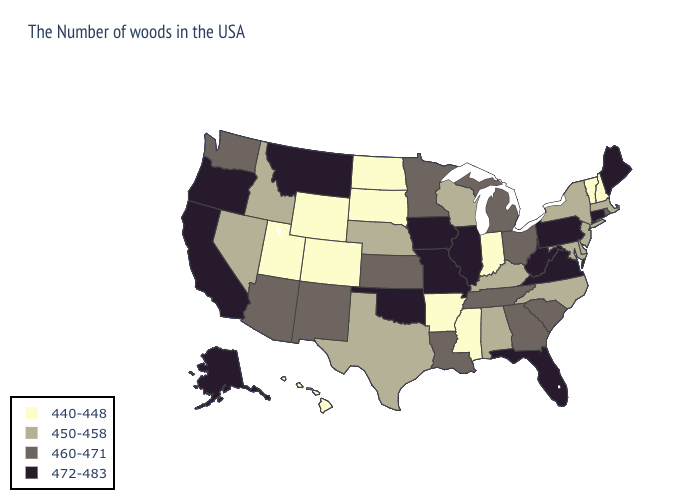Does Louisiana have the lowest value in the South?
Short answer required. No. Does Montana have the highest value in the USA?
Short answer required. Yes. Does Vermont have a lower value than Wyoming?
Keep it brief. No. Does Montana have the highest value in the West?
Keep it brief. Yes. Which states hav the highest value in the Northeast?
Give a very brief answer. Maine, Connecticut, Pennsylvania. Name the states that have a value in the range 472-483?
Write a very short answer. Maine, Connecticut, Pennsylvania, Virginia, West Virginia, Florida, Illinois, Missouri, Iowa, Oklahoma, Montana, California, Oregon, Alaska. What is the highest value in the USA?
Concise answer only. 472-483. What is the lowest value in the USA?
Keep it brief. 440-448. Which states have the lowest value in the USA?
Give a very brief answer. New Hampshire, Vermont, Indiana, Mississippi, Arkansas, South Dakota, North Dakota, Wyoming, Colorado, Utah, Hawaii. Which states hav the highest value in the MidWest?
Quick response, please. Illinois, Missouri, Iowa. What is the lowest value in the MidWest?
Be succinct. 440-448. What is the lowest value in the South?
Quick response, please. 440-448. Name the states that have a value in the range 440-448?
Answer briefly. New Hampshire, Vermont, Indiana, Mississippi, Arkansas, South Dakota, North Dakota, Wyoming, Colorado, Utah, Hawaii. What is the lowest value in the USA?
Write a very short answer. 440-448. Name the states that have a value in the range 460-471?
Quick response, please. Rhode Island, South Carolina, Ohio, Georgia, Michigan, Tennessee, Louisiana, Minnesota, Kansas, New Mexico, Arizona, Washington. 